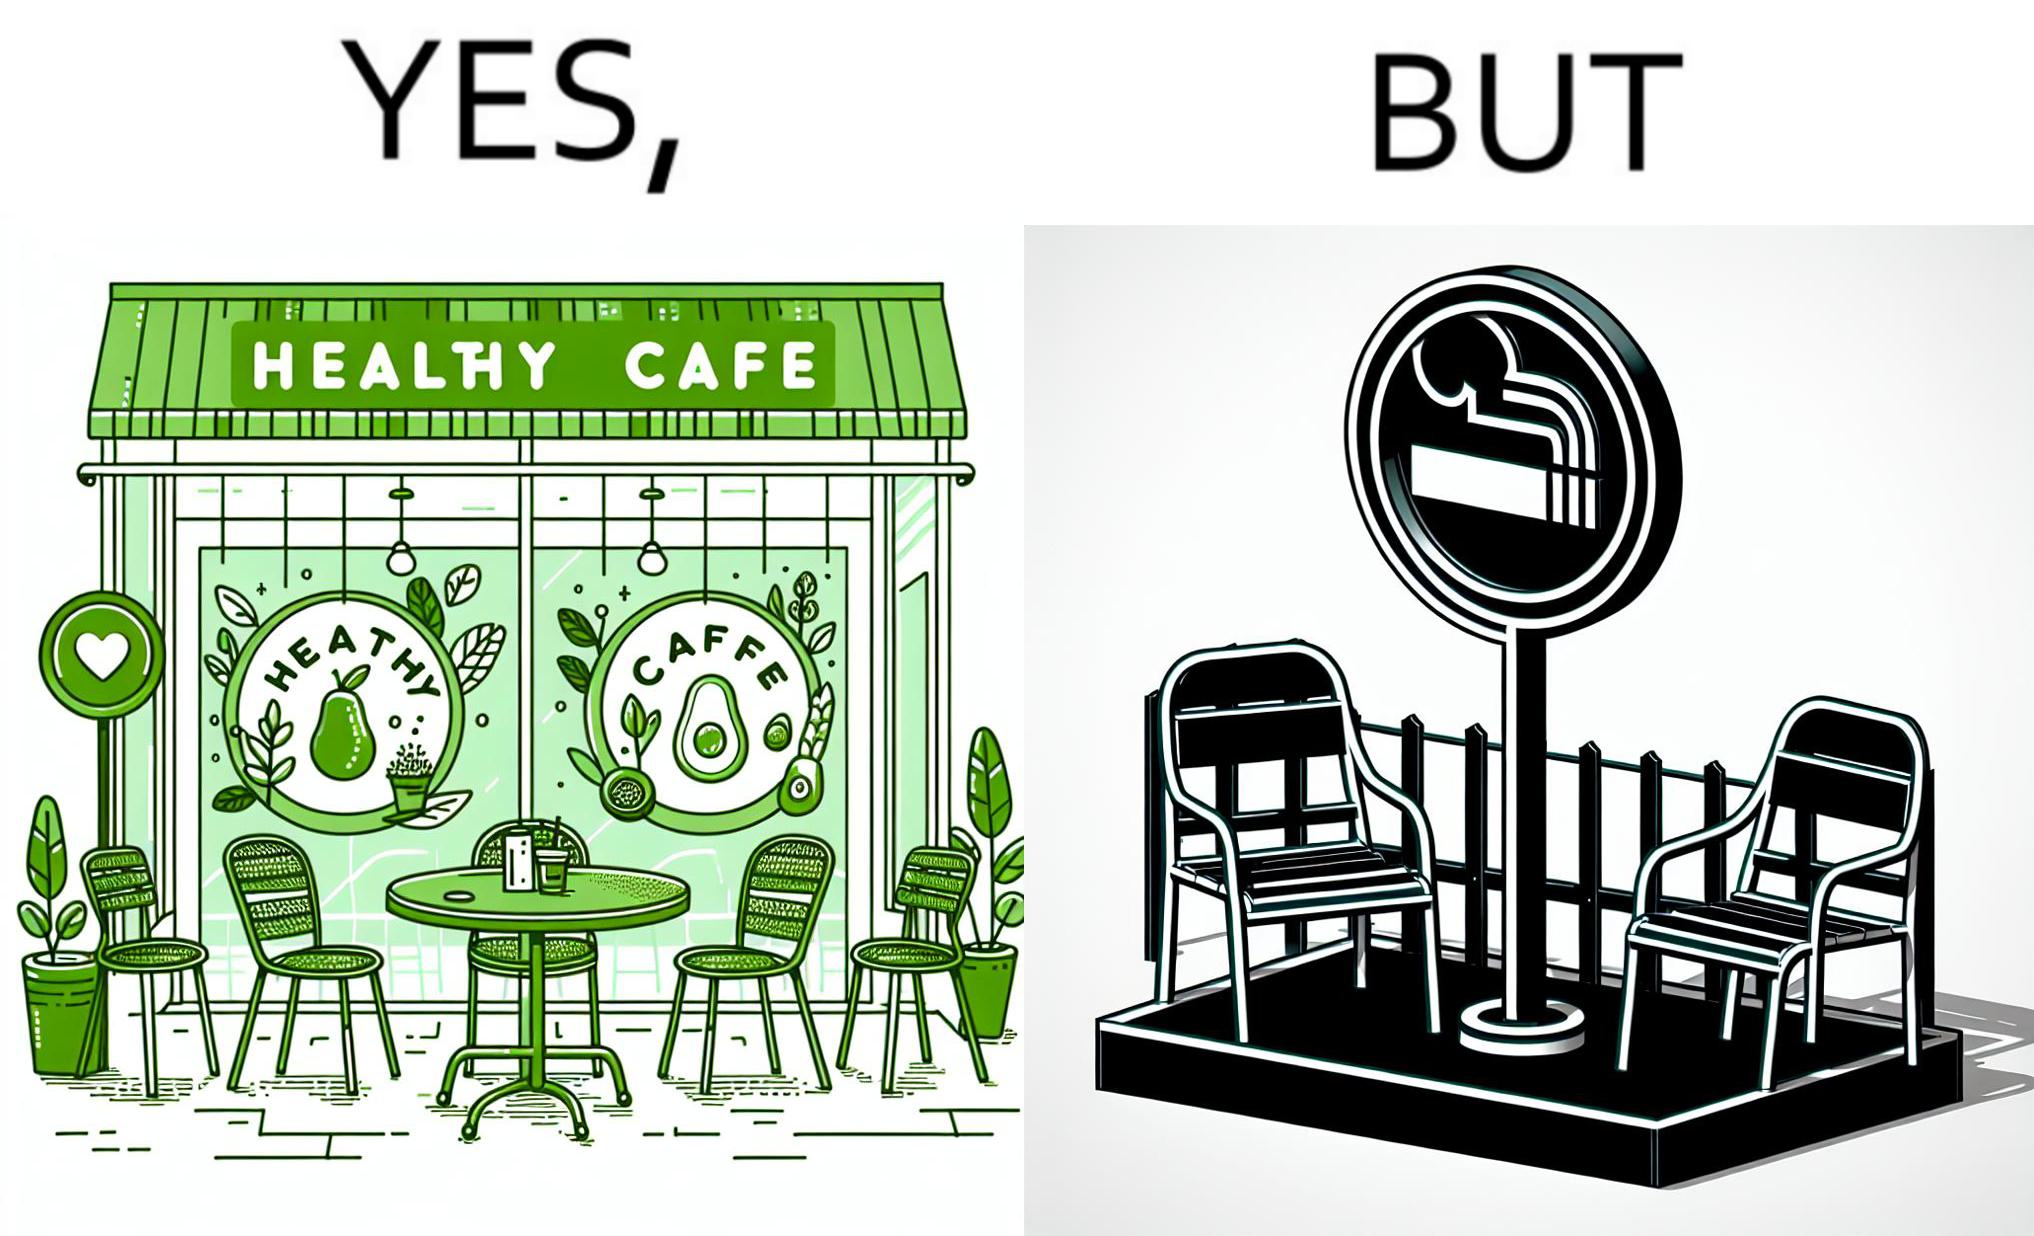Does this image contain satire or humor? Yes, this image is satirical. 